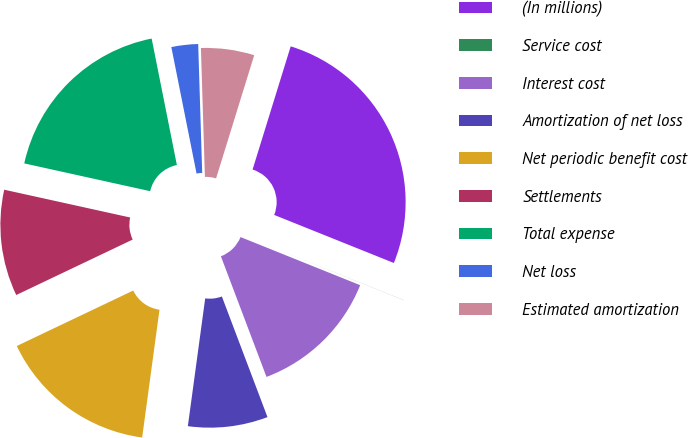<chart> <loc_0><loc_0><loc_500><loc_500><pie_chart><fcel>(In millions)<fcel>Service cost<fcel>Interest cost<fcel>Amortization of net loss<fcel>Net periodic benefit cost<fcel>Settlements<fcel>Total expense<fcel>Net loss<fcel>Estimated amortization<nl><fcel>26.3%<fcel>0.01%<fcel>13.16%<fcel>7.9%<fcel>15.78%<fcel>10.53%<fcel>18.41%<fcel>2.64%<fcel>5.27%<nl></chart> 